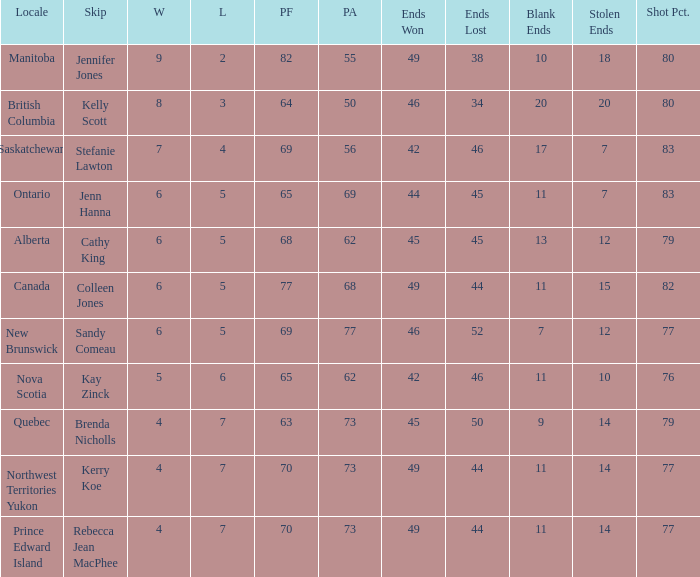What is the minimum performance assessment when 45 ends are lost? 62.0. 